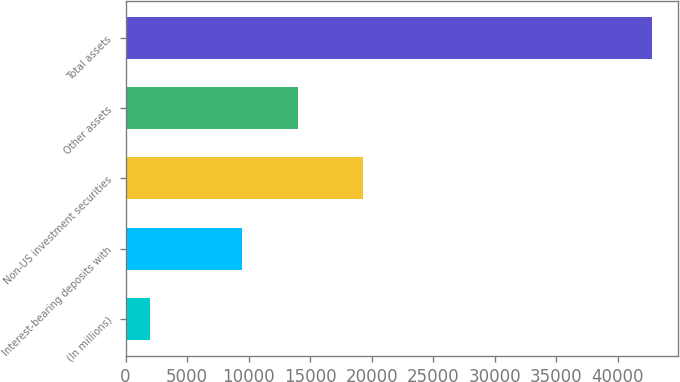Convert chart. <chart><loc_0><loc_0><loc_500><loc_500><bar_chart><fcel>(In millions)<fcel>Interest-bearing deposits with<fcel>Non-US investment securities<fcel>Other assets<fcel>Total assets<nl><fcel>2010<fcel>9443<fcel>19329<fcel>13994<fcel>42766<nl></chart> 